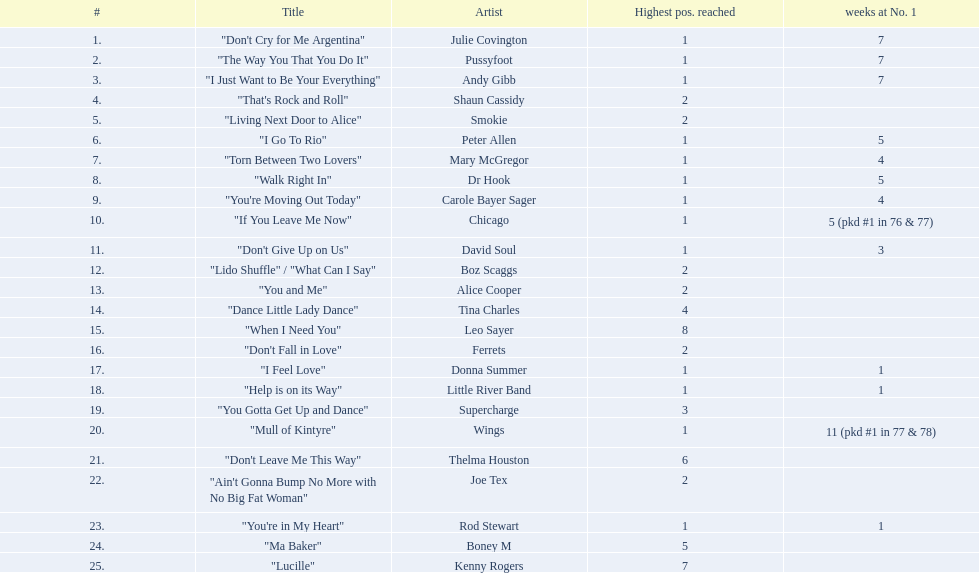What is the maximum duration a song has stayed at the number 1 position? 11 (pkd #1 in 77 & 78). Which song remained at the top spot for 11 weeks? "Mull of Kintyre". Which group achieved a number 1 hit with this particular track? Wings. 